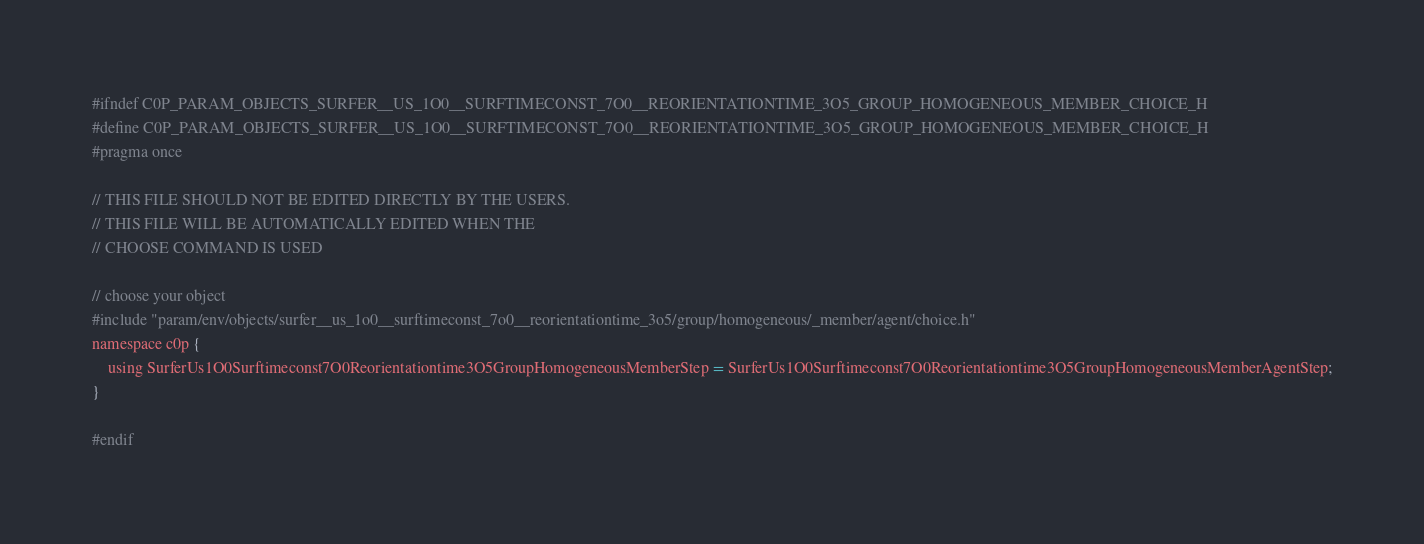Convert code to text. <code><loc_0><loc_0><loc_500><loc_500><_C_>#ifndef C0P_PARAM_OBJECTS_SURFER__US_1O0__SURFTIMECONST_7O0__REORIENTATIONTIME_3O5_GROUP_HOMOGENEOUS_MEMBER_CHOICE_H
#define C0P_PARAM_OBJECTS_SURFER__US_1O0__SURFTIMECONST_7O0__REORIENTATIONTIME_3O5_GROUP_HOMOGENEOUS_MEMBER_CHOICE_H
#pragma once

// THIS FILE SHOULD NOT BE EDITED DIRECTLY BY THE USERS.
// THIS FILE WILL BE AUTOMATICALLY EDITED WHEN THE
// CHOOSE COMMAND IS USED

// choose your object
#include "param/env/objects/surfer__us_1o0__surftimeconst_7o0__reorientationtime_3o5/group/homogeneous/_member/agent/choice.h"
namespace c0p {
    using SurferUs1O0Surftimeconst7O0Reorientationtime3O5GroupHomogeneousMemberStep = SurferUs1O0Surftimeconst7O0Reorientationtime3O5GroupHomogeneousMemberAgentStep;
}

#endif
</code> 